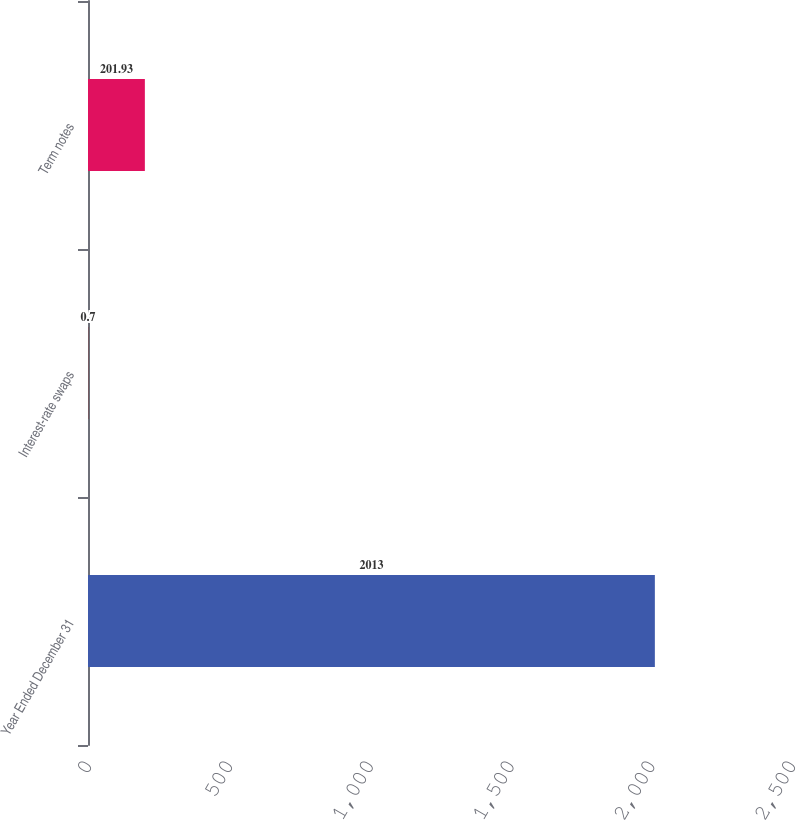Convert chart to OTSL. <chart><loc_0><loc_0><loc_500><loc_500><bar_chart><fcel>Year Ended December 31<fcel>Interest-rate swaps<fcel>Term notes<nl><fcel>2013<fcel>0.7<fcel>201.93<nl></chart> 